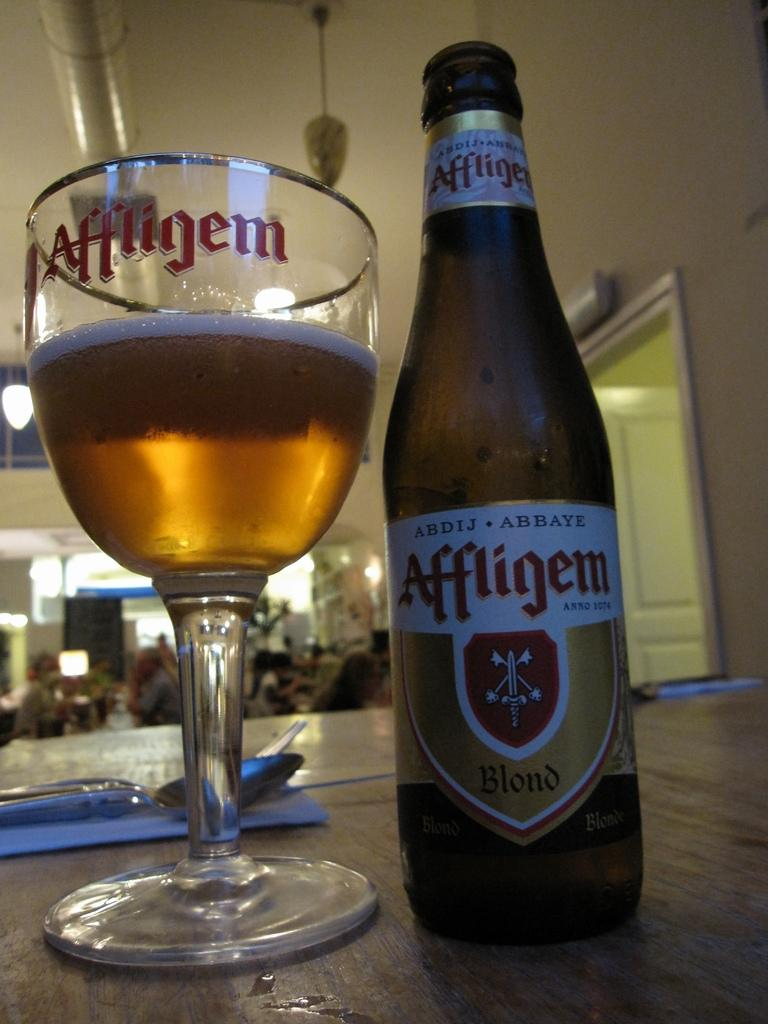<image>
Create a compact narrative representing the image presented. A glass of Affligem blend beer sits next to its bottle. 